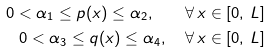<formula> <loc_0><loc_0><loc_500><loc_500>0 < \alpha _ { 1 } \leq p ( x ) \leq \alpha _ { 2 } , \quad \forall \, x \in [ 0 , \, L ] \\ 0 < \alpha _ { 3 } \leq q ( x ) \leq \alpha _ { 4 } , \quad \forall \, x \in [ 0 , \, L ]</formula> 